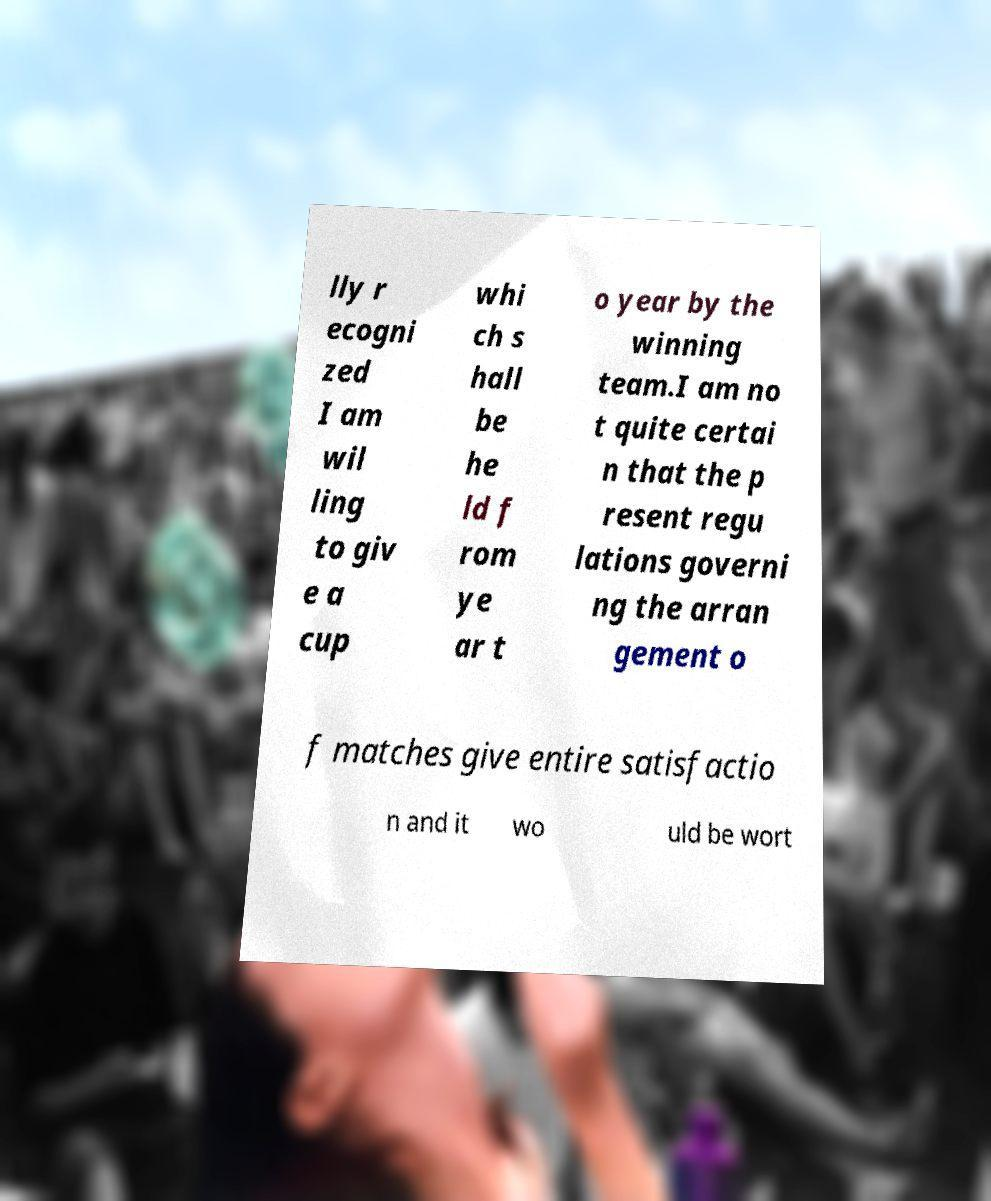There's text embedded in this image that I need extracted. Can you transcribe it verbatim? lly r ecogni zed I am wil ling to giv e a cup whi ch s hall be he ld f rom ye ar t o year by the winning team.I am no t quite certai n that the p resent regu lations governi ng the arran gement o f matches give entire satisfactio n and it wo uld be wort 